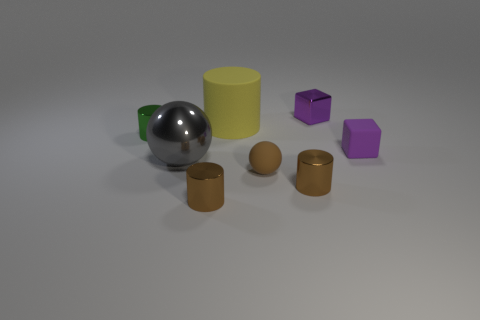Does the tiny metallic cube have the same color as the tiny matte cube?
Keep it short and to the point. Yes. There is a big gray object; what number of small metallic objects are behind it?
Offer a very short reply. 2. Are any large green metallic balls visible?
Ensure brevity in your answer.  No. There is a cube on the right side of the small thing that is behind the object that is left of the large metallic object; what size is it?
Make the answer very short. Small. What number of other things are the same size as the metallic sphere?
Make the answer very short. 1. There is a object behind the rubber cylinder; what size is it?
Ensure brevity in your answer.  Small. Is there anything else that is the same color as the rubber cube?
Offer a terse response. Yes. Do the cube that is behind the small green shiny thing and the big yellow cylinder have the same material?
Your answer should be compact. No. How many things are on the left side of the tiny purple shiny cube and in front of the tiny green cylinder?
Your answer should be compact. 4. There is a purple object behind the small cylinder behind the large ball; how big is it?
Provide a short and direct response. Small. 